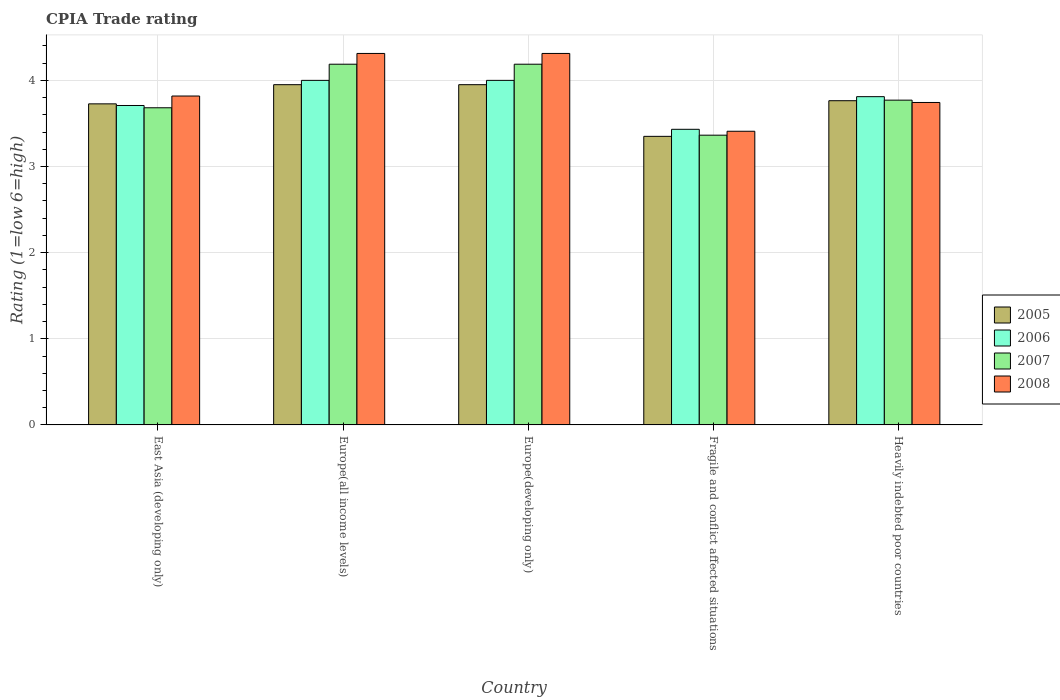How many groups of bars are there?
Provide a short and direct response. 5. Are the number of bars per tick equal to the number of legend labels?
Ensure brevity in your answer.  Yes. What is the label of the 2nd group of bars from the left?
Your response must be concise. Europe(all income levels). What is the CPIA rating in 2007 in Europe(all income levels)?
Provide a short and direct response. 4.19. Across all countries, what is the maximum CPIA rating in 2005?
Keep it short and to the point. 3.95. Across all countries, what is the minimum CPIA rating in 2007?
Ensure brevity in your answer.  3.36. In which country was the CPIA rating in 2005 maximum?
Make the answer very short. Europe(all income levels). In which country was the CPIA rating in 2006 minimum?
Your answer should be compact. Fragile and conflict affected situations. What is the total CPIA rating in 2007 in the graph?
Your answer should be compact. 19.19. What is the difference between the CPIA rating in 2007 in Europe(developing only) and that in Heavily indebted poor countries?
Give a very brief answer. 0.42. What is the difference between the CPIA rating in 2008 in Europe(developing only) and the CPIA rating in 2006 in Fragile and conflict affected situations?
Provide a succinct answer. 0.88. What is the average CPIA rating in 2005 per country?
Offer a terse response. 3.75. What is the difference between the CPIA rating of/in 2008 and CPIA rating of/in 2006 in Europe(all income levels)?
Your answer should be compact. 0.31. In how many countries, is the CPIA rating in 2008 greater than 3.8?
Give a very brief answer. 3. What is the ratio of the CPIA rating in 2007 in East Asia (developing only) to that in Europe(developing only)?
Offer a very short reply. 0.88. What is the difference between the highest and the second highest CPIA rating in 2005?
Your answer should be compact. -0.19. What is the difference between the highest and the lowest CPIA rating in 2005?
Your response must be concise. 0.6. What does the 4th bar from the right in Heavily indebted poor countries represents?
Your response must be concise. 2005. Is it the case that in every country, the sum of the CPIA rating in 2008 and CPIA rating in 2005 is greater than the CPIA rating in 2006?
Offer a terse response. Yes. How many bars are there?
Give a very brief answer. 20. How many countries are there in the graph?
Provide a succinct answer. 5. Are the values on the major ticks of Y-axis written in scientific E-notation?
Provide a succinct answer. No. Does the graph contain grids?
Keep it short and to the point. Yes. How many legend labels are there?
Your answer should be very brief. 4. How are the legend labels stacked?
Keep it short and to the point. Vertical. What is the title of the graph?
Ensure brevity in your answer.  CPIA Trade rating. Does "1993" appear as one of the legend labels in the graph?
Your answer should be compact. No. What is the label or title of the Y-axis?
Your answer should be very brief. Rating (1=low 6=high). What is the Rating (1=low 6=high) in 2005 in East Asia (developing only)?
Provide a succinct answer. 3.73. What is the Rating (1=low 6=high) in 2006 in East Asia (developing only)?
Keep it short and to the point. 3.71. What is the Rating (1=low 6=high) of 2007 in East Asia (developing only)?
Your response must be concise. 3.68. What is the Rating (1=low 6=high) in 2008 in East Asia (developing only)?
Give a very brief answer. 3.82. What is the Rating (1=low 6=high) of 2005 in Europe(all income levels)?
Your response must be concise. 3.95. What is the Rating (1=low 6=high) of 2006 in Europe(all income levels)?
Keep it short and to the point. 4. What is the Rating (1=low 6=high) of 2007 in Europe(all income levels)?
Offer a very short reply. 4.19. What is the Rating (1=low 6=high) in 2008 in Europe(all income levels)?
Your response must be concise. 4.31. What is the Rating (1=low 6=high) of 2005 in Europe(developing only)?
Give a very brief answer. 3.95. What is the Rating (1=low 6=high) in 2006 in Europe(developing only)?
Make the answer very short. 4. What is the Rating (1=low 6=high) in 2007 in Europe(developing only)?
Ensure brevity in your answer.  4.19. What is the Rating (1=low 6=high) in 2008 in Europe(developing only)?
Provide a short and direct response. 4.31. What is the Rating (1=low 6=high) of 2005 in Fragile and conflict affected situations?
Offer a very short reply. 3.35. What is the Rating (1=low 6=high) in 2006 in Fragile and conflict affected situations?
Offer a terse response. 3.43. What is the Rating (1=low 6=high) in 2007 in Fragile and conflict affected situations?
Provide a short and direct response. 3.36. What is the Rating (1=low 6=high) in 2008 in Fragile and conflict affected situations?
Your answer should be compact. 3.41. What is the Rating (1=low 6=high) in 2005 in Heavily indebted poor countries?
Offer a very short reply. 3.76. What is the Rating (1=low 6=high) of 2006 in Heavily indebted poor countries?
Provide a succinct answer. 3.81. What is the Rating (1=low 6=high) in 2007 in Heavily indebted poor countries?
Make the answer very short. 3.77. What is the Rating (1=low 6=high) in 2008 in Heavily indebted poor countries?
Your response must be concise. 3.74. Across all countries, what is the maximum Rating (1=low 6=high) in 2005?
Keep it short and to the point. 3.95. Across all countries, what is the maximum Rating (1=low 6=high) in 2006?
Your answer should be very brief. 4. Across all countries, what is the maximum Rating (1=low 6=high) in 2007?
Provide a succinct answer. 4.19. Across all countries, what is the maximum Rating (1=low 6=high) of 2008?
Provide a succinct answer. 4.31. Across all countries, what is the minimum Rating (1=low 6=high) of 2005?
Your response must be concise. 3.35. Across all countries, what is the minimum Rating (1=low 6=high) of 2006?
Offer a terse response. 3.43. Across all countries, what is the minimum Rating (1=low 6=high) in 2007?
Keep it short and to the point. 3.36. Across all countries, what is the minimum Rating (1=low 6=high) of 2008?
Your response must be concise. 3.41. What is the total Rating (1=low 6=high) in 2005 in the graph?
Make the answer very short. 18.74. What is the total Rating (1=low 6=high) of 2006 in the graph?
Provide a succinct answer. 18.95. What is the total Rating (1=low 6=high) in 2007 in the graph?
Offer a terse response. 19.19. What is the total Rating (1=low 6=high) in 2008 in the graph?
Your answer should be very brief. 19.6. What is the difference between the Rating (1=low 6=high) in 2005 in East Asia (developing only) and that in Europe(all income levels)?
Offer a very short reply. -0.22. What is the difference between the Rating (1=low 6=high) in 2006 in East Asia (developing only) and that in Europe(all income levels)?
Make the answer very short. -0.29. What is the difference between the Rating (1=low 6=high) of 2007 in East Asia (developing only) and that in Europe(all income levels)?
Make the answer very short. -0.51. What is the difference between the Rating (1=low 6=high) in 2008 in East Asia (developing only) and that in Europe(all income levels)?
Your response must be concise. -0.49. What is the difference between the Rating (1=low 6=high) of 2005 in East Asia (developing only) and that in Europe(developing only)?
Your answer should be very brief. -0.22. What is the difference between the Rating (1=low 6=high) in 2006 in East Asia (developing only) and that in Europe(developing only)?
Provide a succinct answer. -0.29. What is the difference between the Rating (1=low 6=high) of 2007 in East Asia (developing only) and that in Europe(developing only)?
Ensure brevity in your answer.  -0.51. What is the difference between the Rating (1=low 6=high) of 2008 in East Asia (developing only) and that in Europe(developing only)?
Offer a very short reply. -0.49. What is the difference between the Rating (1=low 6=high) in 2005 in East Asia (developing only) and that in Fragile and conflict affected situations?
Give a very brief answer. 0.38. What is the difference between the Rating (1=low 6=high) in 2006 in East Asia (developing only) and that in Fragile and conflict affected situations?
Offer a very short reply. 0.28. What is the difference between the Rating (1=low 6=high) of 2007 in East Asia (developing only) and that in Fragile and conflict affected situations?
Offer a terse response. 0.32. What is the difference between the Rating (1=low 6=high) in 2008 in East Asia (developing only) and that in Fragile and conflict affected situations?
Keep it short and to the point. 0.41. What is the difference between the Rating (1=low 6=high) in 2005 in East Asia (developing only) and that in Heavily indebted poor countries?
Offer a very short reply. -0.04. What is the difference between the Rating (1=low 6=high) of 2006 in East Asia (developing only) and that in Heavily indebted poor countries?
Keep it short and to the point. -0.1. What is the difference between the Rating (1=low 6=high) in 2007 in East Asia (developing only) and that in Heavily indebted poor countries?
Your response must be concise. -0.09. What is the difference between the Rating (1=low 6=high) in 2008 in East Asia (developing only) and that in Heavily indebted poor countries?
Make the answer very short. 0.07. What is the difference between the Rating (1=low 6=high) in 2005 in Europe(all income levels) and that in Europe(developing only)?
Offer a very short reply. 0. What is the difference between the Rating (1=low 6=high) of 2006 in Europe(all income levels) and that in Europe(developing only)?
Provide a short and direct response. 0. What is the difference between the Rating (1=low 6=high) in 2005 in Europe(all income levels) and that in Fragile and conflict affected situations?
Your response must be concise. 0.6. What is the difference between the Rating (1=low 6=high) in 2006 in Europe(all income levels) and that in Fragile and conflict affected situations?
Offer a terse response. 0.57. What is the difference between the Rating (1=low 6=high) in 2007 in Europe(all income levels) and that in Fragile and conflict affected situations?
Give a very brief answer. 0.82. What is the difference between the Rating (1=low 6=high) of 2008 in Europe(all income levels) and that in Fragile and conflict affected situations?
Your answer should be very brief. 0.9. What is the difference between the Rating (1=low 6=high) in 2005 in Europe(all income levels) and that in Heavily indebted poor countries?
Offer a very short reply. 0.19. What is the difference between the Rating (1=low 6=high) in 2006 in Europe(all income levels) and that in Heavily indebted poor countries?
Your answer should be very brief. 0.19. What is the difference between the Rating (1=low 6=high) in 2007 in Europe(all income levels) and that in Heavily indebted poor countries?
Your answer should be compact. 0.42. What is the difference between the Rating (1=low 6=high) of 2008 in Europe(all income levels) and that in Heavily indebted poor countries?
Your response must be concise. 0.57. What is the difference between the Rating (1=low 6=high) of 2006 in Europe(developing only) and that in Fragile and conflict affected situations?
Provide a succinct answer. 0.57. What is the difference between the Rating (1=low 6=high) of 2007 in Europe(developing only) and that in Fragile and conflict affected situations?
Keep it short and to the point. 0.82. What is the difference between the Rating (1=low 6=high) in 2008 in Europe(developing only) and that in Fragile and conflict affected situations?
Ensure brevity in your answer.  0.9. What is the difference between the Rating (1=low 6=high) of 2005 in Europe(developing only) and that in Heavily indebted poor countries?
Provide a succinct answer. 0.19. What is the difference between the Rating (1=low 6=high) of 2006 in Europe(developing only) and that in Heavily indebted poor countries?
Provide a succinct answer. 0.19. What is the difference between the Rating (1=low 6=high) of 2007 in Europe(developing only) and that in Heavily indebted poor countries?
Provide a succinct answer. 0.42. What is the difference between the Rating (1=low 6=high) of 2008 in Europe(developing only) and that in Heavily indebted poor countries?
Offer a very short reply. 0.57. What is the difference between the Rating (1=low 6=high) in 2005 in Fragile and conflict affected situations and that in Heavily indebted poor countries?
Your answer should be compact. -0.41. What is the difference between the Rating (1=low 6=high) of 2006 in Fragile and conflict affected situations and that in Heavily indebted poor countries?
Your answer should be compact. -0.38. What is the difference between the Rating (1=low 6=high) in 2007 in Fragile and conflict affected situations and that in Heavily indebted poor countries?
Make the answer very short. -0.41. What is the difference between the Rating (1=low 6=high) of 2008 in Fragile and conflict affected situations and that in Heavily indebted poor countries?
Give a very brief answer. -0.33. What is the difference between the Rating (1=low 6=high) of 2005 in East Asia (developing only) and the Rating (1=low 6=high) of 2006 in Europe(all income levels)?
Your answer should be compact. -0.27. What is the difference between the Rating (1=low 6=high) of 2005 in East Asia (developing only) and the Rating (1=low 6=high) of 2007 in Europe(all income levels)?
Offer a very short reply. -0.46. What is the difference between the Rating (1=low 6=high) in 2005 in East Asia (developing only) and the Rating (1=low 6=high) in 2008 in Europe(all income levels)?
Give a very brief answer. -0.59. What is the difference between the Rating (1=low 6=high) of 2006 in East Asia (developing only) and the Rating (1=low 6=high) of 2007 in Europe(all income levels)?
Your answer should be compact. -0.48. What is the difference between the Rating (1=low 6=high) of 2006 in East Asia (developing only) and the Rating (1=low 6=high) of 2008 in Europe(all income levels)?
Your answer should be compact. -0.6. What is the difference between the Rating (1=low 6=high) in 2007 in East Asia (developing only) and the Rating (1=low 6=high) in 2008 in Europe(all income levels)?
Ensure brevity in your answer.  -0.63. What is the difference between the Rating (1=low 6=high) in 2005 in East Asia (developing only) and the Rating (1=low 6=high) in 2006 in Europe(developing only)?
Offer a very short reply. -0.27. What is the difference between the Rating (1=low 6=high) in 2005 in East Asia (developing only) and the Rating (1=low 6=high) in 2007 in Europe(developing only)?
Your answer should be compact. -0.46. What is the difference between the Rating (1=low 6=high) in 2005 in East Asia (developing only) and the Rating (1=low 6=high) in 2008 in Europe(developing only)?
Provide a short and direct response. -0.59. What is the difference between the Rating (1=low 6=high) in 2006 in East Asia (developing only) and the Rating (1=low 6=high) in 2007 in Europe(developing only)?
Provide a succinct answer. -0.48. What is the difference between the Rating (1=low 6=high) in 2006 in East Asia (developing only) and the Rating (1=low 6=high) in 2008 in Europe(developing only)?
Your response must be concise. -0.6. What is the difference between the Rating (1=low 6=high) of 2007 in East Asia (developing only) and the Rating (1=low 6=high) of 2008 in Europe(developing only)?
Provide a short and direct response. -0.63. What is the difference between the Rating (1=low 6=high) of 2005 in East Asia (developing only) and the Rating (1=low 6=high) of 2006 in Fragile and conflict affected situations?
Offer a very short reply. 0.3. What is the difference between the Rating (1=low 6=high) in 2005 in East Asia (developing only) and the Rating (1=low 6=high) in 2007 in Fragile and conflict affected situations?
Make the answer very short. 0.36. What is the difference between the Rating (1=low 6=high) in 2005 in East Asia (developing only) and the Rating (1=low 6=high) in 2008 in Fragile and conflict affected situations?
Offer a very short reply. 0.32. What is the difference between the Rating (1=low 6=high) in 2006 in East Asia (developing only) and the Rating (1=low 6=high) in 2007 in Fragile and conflict affected situations?
Your answer should be compact. 0.34. What is the difference between the Rating (1=low 6=high) in 2006 in East Asia (developing only) and the Rating (1=low 6=high) in 2008 in Fragile and conflict affected situations?
Provide a succinct answer. 0.3. What is the difference between the Rating (1=low 6=high) of 2007 in East Asia (developing only) and the Rating (1=low 6=high) of 2008 in Fragile and conflict affected situations?
Keep it short and to the point. 0.27. What is the difference between the Rating (1=low 6=high) in 2005 in East Asia (developing only) and the Rating (1=low 6=high) in 2006 in Heavily indebted poor countries?
Your response must be concise. -0.08. What is the difference between the Rating (1=low 6=high) in 2005 in East Asia (developing only) and the Rating (1=low 6=high) in 2007 in Heavily indebted poor countries?
Offer a very short reply. -0.04. What is the difference between the Rating (1=low 6=high) in 2005 in East Asia (developing only) and the Rating (1=low 6=high) in 2008 in Heavily indebted poor countries?
Provide a short and direct response. -0.02. What is the difference between the Rating (1=low 6=high) of 2006 in East Asia (developing only) and the Rating (1=low 6=high) of 2007 in Heavily indebted poor countries?
Make the answer very short. -0.06. What is the difference between the Rating (1=low 6=high) in 2006 in East Asia (developing only) and the Rating (1=low 6=high) in 2008 in Heavily indebted poor countries?
Ensure brevity in your answer.  -0.03. What is the difference between the Rating (1=low 6=high) in 2007 in East Asia (developing only) and the Rating (1=low 6=high) in 2008 in Heavily indebted poor countries?
Provide a short and direct response. -0.06. What is the difference between the Rating (1=low 6=high) in 2005 in Europe(all income levels) and the Rating (1=low 6=high) in 2007 in Europe(developing only)?
Provide a short and direct response. -0.24. What is the difference between the Rating (1=low 6=high) of 2005 in Europe(all income levels) and the Rating (1=low 6=high) of 2008 in Europe(developing only)?
Ensure brevity in your answer.  -0.36. What is the difference between the Rating (1=low 6=high) of 2006 in Europe(all income levels) and the Rating (1=low 6=high) of 2007 in Europe(developing only)?
Provide a succinct answer. -0.19. What is the difference between the Rating (1=low 6=high) of 2006 in Europe(all income levels) and the Rating (1=low 6=high) of 2008 in Europe(developing only)?
Keep it short and to the point. -0.31. What is the difference between the Rating (1=low 6=high) of 2007 in Europe(all income levels) and the Rating (1=low 6=high) of 2008 in Europe(developing only)?
Offer a very short reply. -0.12. What is the difference between the Rating (1=low 6=high) of 2005 in Europe(all income levels) and the Rating (1=low 6=high) of 2006 in Fragile and conflict affected situations?
Provide a succinct answer. 0.52. What is the difference between the Rating (1=low 6=high) in 2005 in Europe(all income levels) and the Rating (1=low 6=high) in 2007 in Fragile and conflict affected situations?
Give a very brief answer. 0.59. What is the difference between the Rating (1=low 6=high) of 2005 in Europe(all income levels) and the Rating (1=low 6=high) of 2008 in Fragile and conflict affected situations?
Your answer should be very brief. 0.54. What is the difference between the Rating (1=low 6=high) in 2006 in Europe(all income levels) and the Rating (1=low 6=high) in 2007 in Fragile and conflict affected situations?
Provide a short and direct response. 0.64. What is the difference between the Rating (1=low 6=high) in 2006 in Europe(all income levels) and the Rating (1=low 6=high) in 2008 in Fragile and conflict affected situations?
Your answer should be compact. 0.59. What is the difference between the Rating (1=low 6=high) of 2007 in Europe(all income levels) and the Rating (1=low 6=high) of 2008 in Fragile and conflict affected situations?
Offer a terse response. 0.78. What is the difference between the Rating (1=low 6=high) of 2005 in Europe(all income levels) and the Rating (1=low 6=high) of 2006 in Heavily indebted poor countries?
Your response must be concise. 0.14. What is the difference between the Rating (1=low 6=high) of 2005 in Europe(all income levels) and the Rating (1=low 6=high) of 2007 in Heavily indebted poor countries?
Provide a short and direct response. 0.18. What is the difference between the Rating (1=low 6=high) of 2005 in Europe(all income levels) and the Rating (1=low 6=high) of 2008 in Heavily indebted poor countries?
Keep it short and to the point. 0.21. What is the difference between the Rating (1=low 6=high) of 2006 in Europe(all income levels) and the Rating (1=low 6=high) of 2007 in Heavily indebted poor countries?
Offer a terse response. 0.23. What is the difference between the Rating (1=low 6=high) of 2006 in Europe(all income levels) and the Rating (1=low 6=high) of 2008 in Heavily indebted poor countries?
Provide a short and direct response. 0.26. What is the difference between the Rating (1=low 6=high) of 2007 in Europe(all income levels) and the Rating (1=low 6=high) of 2008 in Heavily indebted poor countries?
Make the answer very short. 0.44. What is the difference between the Rating (1=low 6=high) of 2005 in Europe(developing only) and the Rating (1=low 6=high) of 2006 in Fragile and conflict affected situations?
Provide a succinct answer. 0.52. What is the difference between the Rating (1=low 6=high) of 2005 in Europe(developing only) and the Rating (1=low 6=high) of 2007 in Fragile and conflict affected situations?
Provide a short and direct response. 0.59. What is the difference between the Rating (1=low 6=high) in 2005 in Europe(developing only) and the Rating (1=low 6=high) in 2008 in Fragile and conflict affected situations?
Offer a very short reply. 0.54. What is the difference between the Rating (1=low 6=high) of 2006 in Europe(developing only) and the Rating (1=low 6=high) of 2007 in Fragile and conflict affected situations?
Ensure brevity in your answer.  0.64. What is the difference between the Rating (1=low 6=high) of 2006 in Europe(developing only) and the Rating (1=low 6=high) of 2008 in Fragile and conflict affected situations?
Provide a succinct answer. 0.59. What is the difference between the Rating (1=low 6=high) of 2007 in Europe(developing only) and the Rating (1=low 6=high) of 2008 in Fragile and conflict affected situations?
Offer a terse response. 0.78. What is the difference between the Rating (1=low 6=high) in 2005 in Europe(developing only) and the Rating (1=low 6=high) in 2006 in Heavily indebted poor countries?
Your response must be concise. 0.14. What is the difference between the Rating (1=low 6=high) of 2005 in Europe(developing only) and the Rating (1=low 6=high) of 2007 in Heavily indebted poor countries?
Offer a terse response. 0.18. What is the difference between the Rating (1=low 6=high) of 2005 in Europe(developing only) and the Rating (1=low 6=high) of 2008 in Heavily indebted poor countries?
Provide a short and direct response. 0.21. What is the difference between the Rating (1=low 6=high) in 2006 in Europe(developing only) and the Rating (1=low 6=high) in 2007 in Heavily indebted poor countries?
Give a very brief answer. 0.23. What is the difference between the Rating (1=low 6=high) in 2006 in Europe(developing only) and the Rating (1=low 6=high) in 2008 in Heavily indebted poor countries?
Your response must be concise. 0.26. What is the difference between the Rating (1=low 6=high) in 2007 in Europe(developing only) and the Rating (1=low 6=high) in 2008 in Heavily indebted poor countries?
Your answer should be very brief. 0.44. What is the difference between the Rating (1=low 6=high) of 2005 in Fragile and conflict affected situations and the Rating (1=low 6=high) of 2006 in Heavily indebted poor countries?
Give a very brief answer. -0.46. What is the difference between the Rating (1=low 6=high) in 2005 in Fragile and conflict affected situations and the Rating (1=low 6=high) in 2007 in Heavily indebted poor countries?
Offer a terse response. -0.42. What is the difference between the Rating (1=low 6=high) in 2005 in Fragile and conflict affected situations and the Rating (1=low 6=high) in 2008 in Heavily indebted poor countries?
Keep it short and to the point. -0.39. What is the difference between the Rating (1=low 6=high) of 2006 in Fragile and conflict affected situations and the Rating (1=low 6=high) of 2007 in Heavily indebted poor countries?
Offer a very short reply. -0.34. What is the difference between the Rating (1=low 6=high) in 2006 in Fragile and conflict affected situations and the Rating (1=low 6=high) in 2008 in Heavily indebted poor countries?
Your answer should be very brief. -0.31. What is the difference between the Rating (1=low 6=high) in 2007 in Fragile and conflict affected situations and the Rating (1=low 6=high) in 2008 in Heavily indebted poor countries?
Offer a terse response. -0.38. What is the average Rating (1=low 6=high) in 2005 per country?
Keep it short and to the point. 3.75. What is the average Rating (1=low 6=high) of 2006 per country?
Provide a short and direct response. 3.79. What is the average Rating (1=low 6=high) in 2007 per country?
Keep it short and to the point. 3.84. What is the average Rating (1=low 6=high) of 2008 per country?
Provide a succinct answer. 3.92. What is the difference between the Rating (1=low 6=high) in 2005 and Rating (1=low 6=high) in 2006 in East Asia (developing only)?
Your answer should be compact. 0.02. What is the difference between the Rating (1=low 6=high) in 2005 and Rating (1=low 6=high) in 2007 in East Asia (developing only)?
Offer a terse response. 0.05. What is the difference between the Rating (1=low 6=high) of 2005 and Rating (1=low 6=high) of 2008 in East Asia (developing only)?
Give a very brief answer. -0.09. What is the difference between the Rating (1=low 6=high) in 2006 and Rating (1=low 6=high) in 2007 in East Asia (developing only)?
Your response must be concise. 0.03. What is the difference between the Rating (1=low 6=high) of 2006 and Rating (1=low 6=high) of 2008 in East Asia (developing only)?
Provide a short and direct response. -0.11. What is the difference between the Rating (1=low 6=high) of 2007 and Rating (1=low 6=high) of 2008 in East Asia (developing only)?
Give a very brief answer. -0.14. What is the difference between the Rating (1=low 6=high) of 2005 and Rating (1=low 6=high) of 2007 in Europe(all income levels)?
Give a very brief answer. -0.24. What is the difference between the Rating (1=low 6=high) in 2005 and Rating (1=low 6=high) in 2008 in Europe(all income levels)?
Provide a succinct answer. -0.36. What is the difference between the Rating (1=low 6=high) of 2006 and Rating (1=low 6=high) of 2007 in Europe(all income levels)?
Make the answer very short. -0.19. What is the difference between the Rating (1=low 6=high) of 2006 and Rating (1=low 6=high) of 2008 in Europe(all income levels)?
Ensure brevity in your answer.  -0.31. What is the difference between the Rating (1=low 6=high) of 2007 and Rating (1=low 6=high) of 2008 in Europe(all income levels)?
Your answer should be very brief. -0.12. What is the difference between the Rating (1=low 6=high) in 2005 and Rating (1=low 6=high) in 2006 in Europe(developing only)?
Ensure brevity in your answer.  -0.05. What is the difference between the Rating (1=low 6=high) of 2005 and Rating (1=low 6=high) of 2007 in Europe(developing only)?
Provide a short and direct response. -0.24. What is the difference between the Rating (1=low 6=high) in 2005 and Rating (1=low 6=high) in 2008 in Europe(developing only)?
Offer a very short reply. -0.36. What is the difference between the Rating (1=low 6=high) in 2006 and Rating (1=low 6=high) in 2007 in Europe(developing only)?
Offer a terse response. -0.19. What is the difference between the Rating (1=low 6=high) in 2006 and Rating (1=low 6=high) in 2008 in Europe(developing only)?
Offer a very short reply. -0.31. What is the difference between the Rating (1=low 6=high) in 2007 and Rating (1=low 6=high) in 2008 in Europe(developing only)?
Offer a very short reply. -0.12. What is the difference between the Rating (1=low 6=high) of 2005 and Rating (1=low 6=high) of 2006 in Fragile and conflict affected situations?
Your answer should be very brief. -0.08. What is the difference between the Rating (1=low 6=high) in 2005 and Rating (1=low 6=high) in 2007 in Fragile and conflict affected situations?
Offer a very short reply. -0.01. What is the difference between the Rating (1=low 6=high) in 2005 and Rating (1=low 6=high) in 2008 in Fragile and conflict affected situations?
Your answer should be compact. -0.06. What is the difference between the Rating (1=low 6=high) of 2006 and Rating (1=low 6=high) of 2007 in Fragile and conflict affected situations?
Offer a very short reply. 0.07. What is the difference between the Rating (1=low 6=high) of 2006 and Rating (1=low 6=high) of 2008 in Fragile and conflict affected situations?
Provide a succinct answer. 0.02. What is the difference between the Rating (1=low 6=high) in 2007 and Rating (1=low 6=high) in 2008 in Fragile and conflict affected situations?
Make the answer very short. -0.05. What is the difference between the Rating (1=low 6=high) of 2005 and Rating (1=low 6=high) of 2006 in Heavily indebted poor countries?
Make the answer very short. -0.05. What is the difference between the Rating (1=low 6=high) of 2005 and Rating (1=low 6=high) of 2007 in Heavily indebted poor countries?
Make the answer very short. -0.01. What is the difference between the Rating (1=low 6=high) in 2005 and Rating (1=low 6=high) in 2008 in Heavily indebted poor countries?
Give a very brief answer. 0.02. What is the difference between the Rating (1=low 6=high) in 2006 and Rating (1=low 6=high) in 2007 in Heavily indebted poor countries?
Provide a short and direct response. 0.04. What is the difference between the Rating (1=low 6=high) of 2006 and Rating (1=low 6=high) of 2008 in Heavily indebted poor countries?
Provide a short and direct response. 0.07. What is the difference between the Rating (1=low 6=high) of 2007 and Rating (1=low 6=high) of 2008 in Heavily indebted poor countries?
Ensure brevity in your answer.  0.03. What is the ratio of the Rating (1=low 6=high) in 2005 in East Asia (developing only) to that in Europe(all income levels)?
Ensure brevity in your answer.  0.94. What is the ratio of the Rating (1=low 6=high) in 2006 in East Asia (developing only) to that in Europe(all income levels)?
Your response must be concise. 0.93. What is the ratio of the Rating (1=low 6=high) in 2007 in East Asia (developing only) to that in Europe(all income levels)?
Keep it short and to the point. 0.88. What is the ratio of the Rating (1=low 6=high) of 2008 in East Asia (developing only) to that in Europe(all income levels)?
Your response must be concise. 0.89. What is the ratio of the Rating (1=low 6=high) in 2005 in East Asia (developing only) to that in Europe(developing only)?
Provide a succinct answer. 0.94. What is the ratio of the Rating (1=low 6=high) of 2006 in East Asia (developing only) to that in Europe(developing only)?
Your response must be concise. 0.93. What is the ratio of the Rating (1=low 6=high) of 2007 in East Asia (developing only) to that in Europe(developing only)?
Offer a terse response. 0.88. What is the ratio of the Rating (1=low 6=high) in 2008 in East Asia (developing only) to that in Europe(developing only)?
Provide a succinct answer. 0.89. What is the ratio of the Rating (1=low 6=high) in 2005 in East Asia (developing only) to that in Fragile and conflict affected situations?
Your response must be concise. 1.11. What is the ratio of the Rating (1=low 6=high) of 2006 in East Asia (developing only) to that in Fragile and conflict affected situations?
Ensure brevity in your answer.  1.08. What is the ratio of the Rating (1=low 6=high) in 2007 in East Asia (developing only) to that in Fragile and conflict affected situations?
Your response must be concise. 1.09. What is the ratio of the Rating (1=low 6=high) of 2008 in East Asia (developing only) to that in Fragile and conflict affected situations?
Offer a terse response. 1.12. What is the ratio of the Rating (1=low 6=high) in 2005 in East Asia (developing only) to that in Heavily indebted poor countries?
Ensure brevity in your answer.  0.99. What is the ratio of the Rating (1=low 6=high) of 2006 in East Asia (developing only) to that in Heavily indebted poor countries?
Provide a short and direct response. 0.97. What is the ratio of the Rating (1=low 6=high) in 2007 in East Asia (developing only) to that in Heavily indebted poor countries?
Provide a short and direct response. 0.98. What is the ratio of the Rating (1=low 6=high) in 2008 in East Asia (developing only) to that in Heavily indebted poor countries?
Your answer should be very brief. 1.02. What is the ratio of the Rating (1=low 6=high) in 2005 in Europe(all income levels) to that in Fragile and conflict affected situations?
Give a very brief answer. 1.18. What is the ratio of the Rating (1=low 6=high) in 2006 in Europe(all income levels) to that in Fragile and conflict affected situations?
Offer a very short reply. 1.17. What is the ratio of the Rating (1=low 6=high) of 2007 in Europe(all income levels) to that in Fragile and conflict affected situations?
Provide a succinct answer. 1.24. What is the ratio of the Rating (1=low 6=high) in 2008 in Europe(all income levels) to that in Fragile and conflict affected situations?
Give a very brief answer. 1.26. What is the ratio of the Rating (1=low 6=high) of 2005 in Europe(all income levels) to that in Heavily indebted poor countries?
Make the answer very short. 1.05. What is the ratio of the Rating (1=low 6=high) in 2006 in Europe(all income levels) to that in Heavily indebted poor countries?
Keep it short and to the point. 1.05. What is the ratio of the Rating (1=low 6=high) of 2007 in Europe(all income levels) to that in Heavily indebted poor countries?
Ensure brevity in your answer.  1.11. What is the ratio of the Rating (1=low 6=high) of 2008 in Europe(all income levels) to that in Heavily indebted poor countries?
Offer a very short reply. 1.15. What is the ratio of the Rating (1=low 6=high) in 2005 in Europe(developing only) to that in Fragile and conflict affected situations?
Make the answer very short. 1.18. What is the ratio of the Rating (1=low 6=high) in 2006 in Europe(developing only) to that in Fragile and conflict affected situations?
Offer a terse response. 1.17. What is the ratio of the Rating (1=low 6=high) in 2007 in Europe(developing only) to that in Fragile and conflict affected situations?
Give a very brief answer. 1.24. What is the ratio of the Rating (1=low 6=high) in 2008 in Europe(developing only) to that in Fragile and conflict affected situations?
Provide a short and direct response. 1.26. What is the ratio of the Rating (1=low 6=high) of 2005 in Europe(developing only) to that in Heavily indebted poor countries?
Offer a very short reply. 1.05. What is the ratio of the Rating (1=low 6=high) of 2006 in Europe(developing only) to that in Heavily indebted poor countries?
Give a very brief answer. 1.05. What is the ratio of the Rating (1=low 6=high) of 2007 in Europe(developing only) to that in Heavily indebted poor countries?
Your answer should be compact. 1.11. What is the ratio of the Rating (1=low 6=high) of 2008 in Europe(developing only) to that in Heavily indebted poor countries?
Offer a terse response. 1.15. What is the ratio of the Rating (1=low 6=high) of 2005 in Fragile and conflict affected situations to that in Heavily indebted poor countries?
Provide a short and direct response. 0.89. What is the ratio of the Rating (1=low 6=high) in 2006 in Fragile and conflict affected situations to that in Heavily indebted poor countries?
Ensure brevity in your answer.  0.9. What is the ratio of the Rating (1=low 6=high) of 2007 in Fragile and conflict affected situations to that in Heavily indebted poor countries?
Provide a succinct answer. 0.89. What is the ratio of the Rating (1=low 6=high) of 2008 in Fragile and conflict affected situations to that in Heavily indebted poor countries?
Your answer should be very brief. 0.91. What is the difference between the highest and the second highest Rating (1=low 6=high) of 2006?
Keep it short and to the point. 0. What is the difference between the highest and the second highest Rating (1=low 6=high) of 2008?
Offer a very short reply. 0. What is the difference between the highest and the lowest Rating (1=low 6=high) in 2006?
Your answer should be compact. 0.57. What is the difference between the highest and the lowest Rating (1=low 6=high) of 2007?
Your answer should be compact. 0.82. What is the difference between the highest and the lowest Rating (1=low 6=high) in 2008?
Provide a succinct answer. 0.9. 